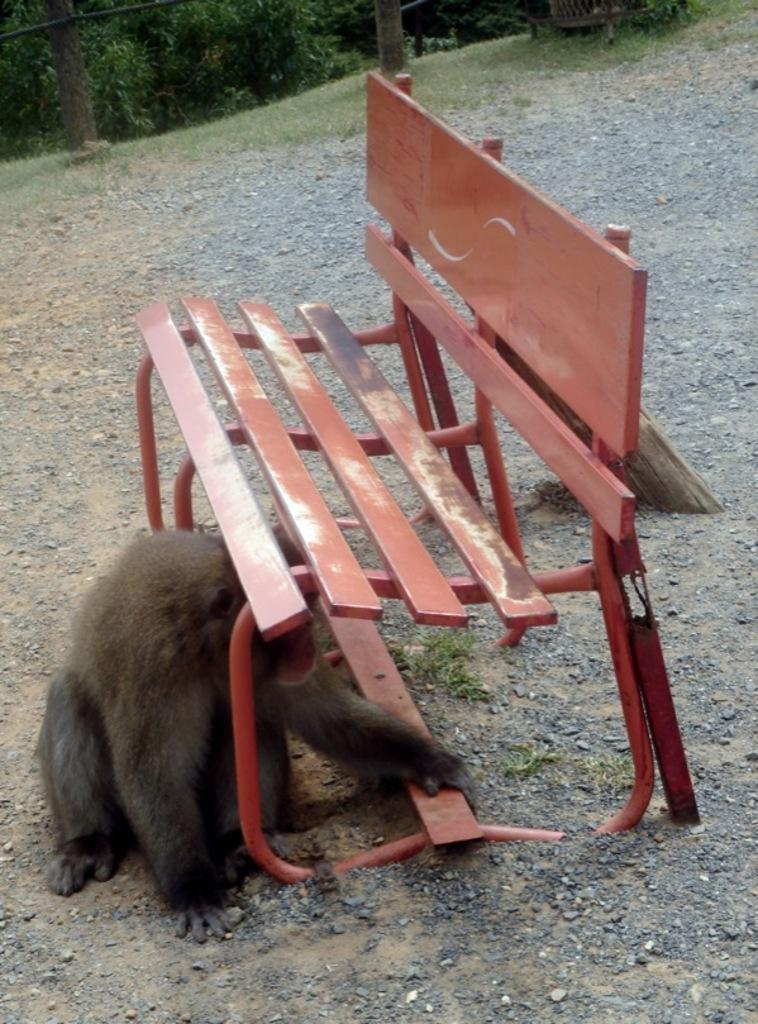What type of seating is present in the image? There is a bench in the image. What other living creature can be seen in the image? There is an animal in the image. What type of vegetation is visible in the image? There is grass in the image. What can be seen in the background of the image? There are trees in the background of the image. Where is the hydrant located in the image? There is no hydrant present in the image. What type of house is visible in the image? There is no house present in the image. 